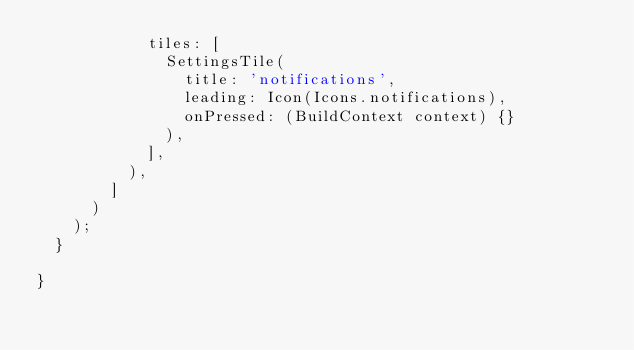Convert code to text. <code><loc_0><loc_0><loc_500><loc_500><_Dart_>            tiles: [
              SettingsTile(
                title: 'notifications',
                leading: Icon(Icons.notifications),
                onPressed: (BuildContext context) {}
              ),
            ],
          ),
        ]
      )
    );
  }

}

</code> 